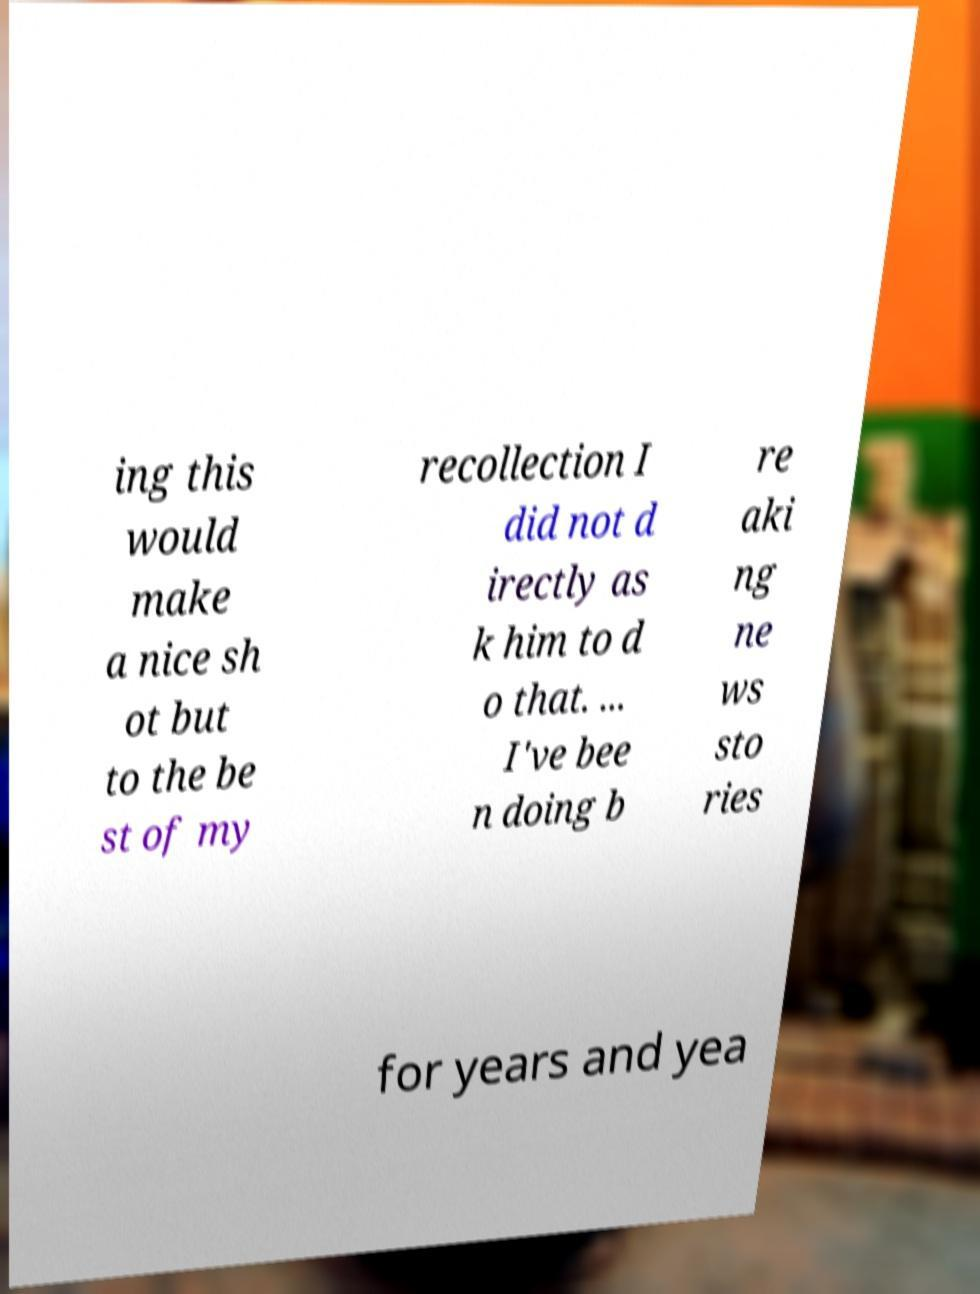I need the written content from this picture converted into text. Can you do that? ing this would make a nice sh ot but to the be st of my recollection I did not d irectly as k him to d o that. ... I've bee n doing b re aki ng ne ws sto ries for years and yea 